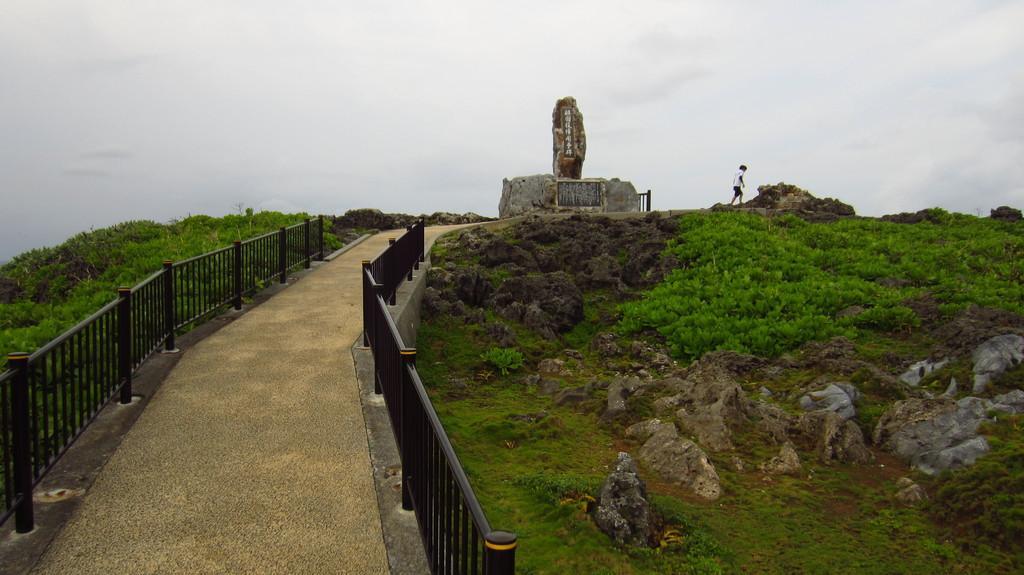How would you summarize this image in a sentence or two? In this picture we can see railings in the front, on the right side and left side there are plants, we can see a person and a memorial in the middle, there are rocks on the right side, we can see the sky at the top of the picture. 